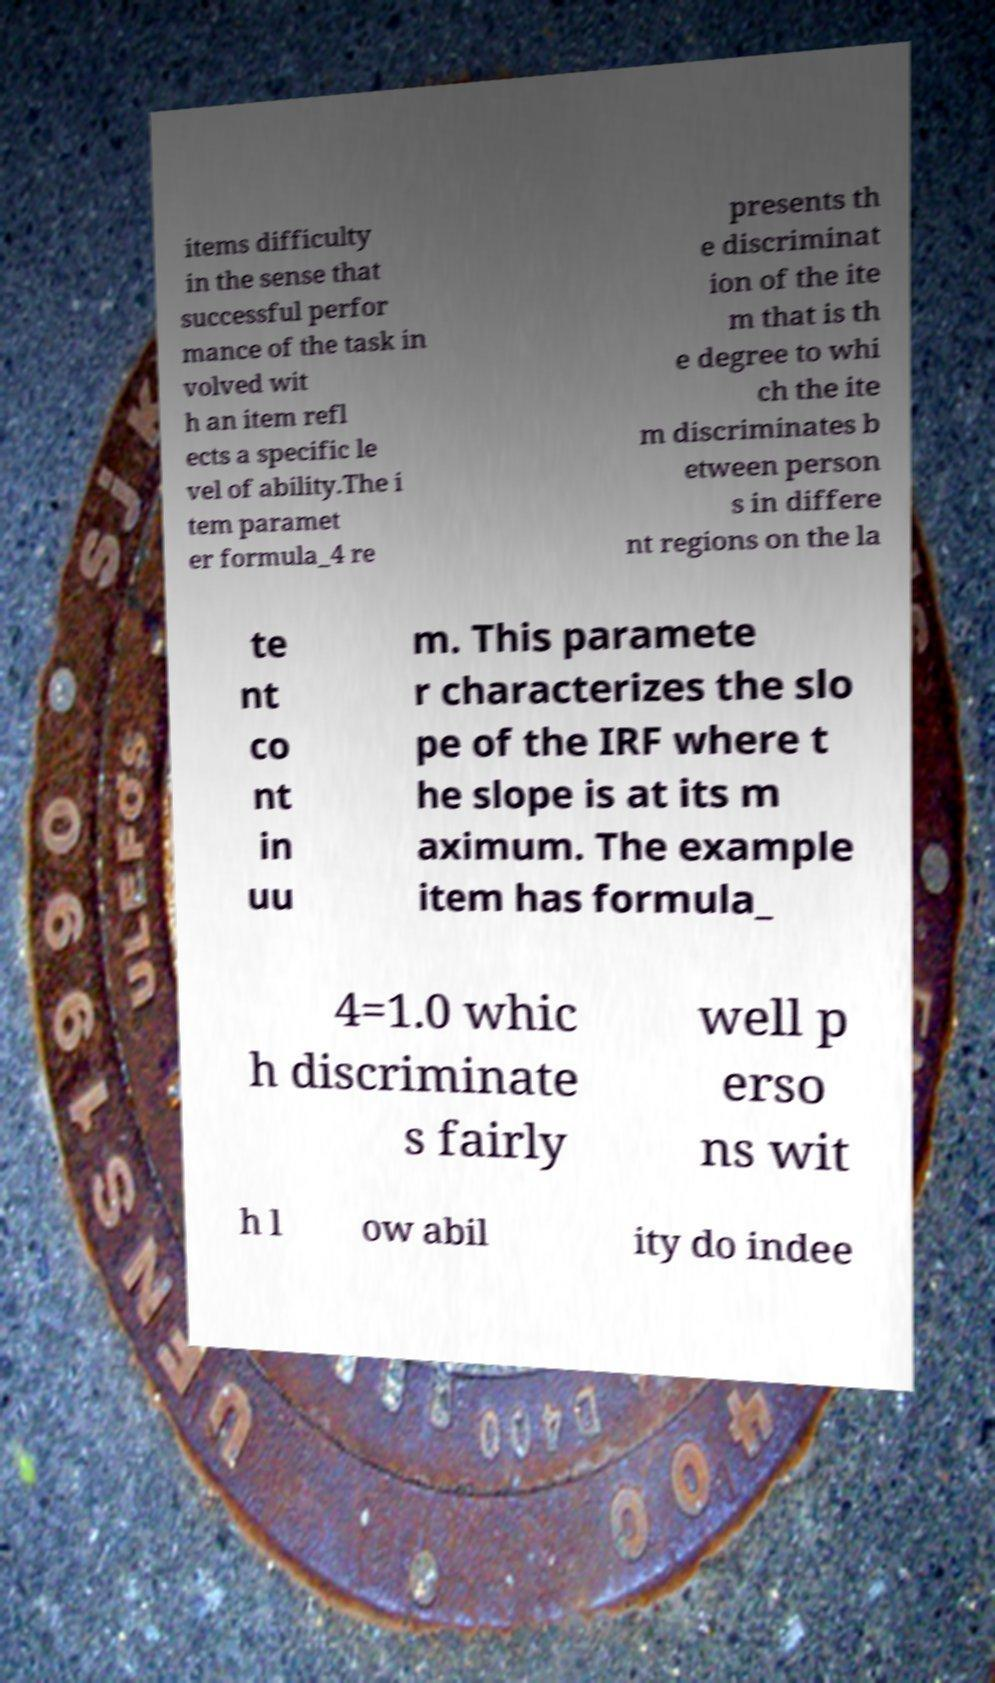I need the written content from this picture converted into text. Can you do that? items difficulty in the sense that successful perfor mance of the task in volved wit h an item refl ects a specific le vel of ability.The i tem paramet er formula_4 re presents th e discriminat ion of the ite m that is th e degree to whi ch the ite m discriminates b etween person s in differe nt regions on the la te nt co nt in uu m. This paramete r characterizes the slo pe of the IRF where t he slope is at its m aximum. The example item has formula_ 4=1.0 whic h discriminate s fairly well p erso ns wit h l ow abil ity do indee 